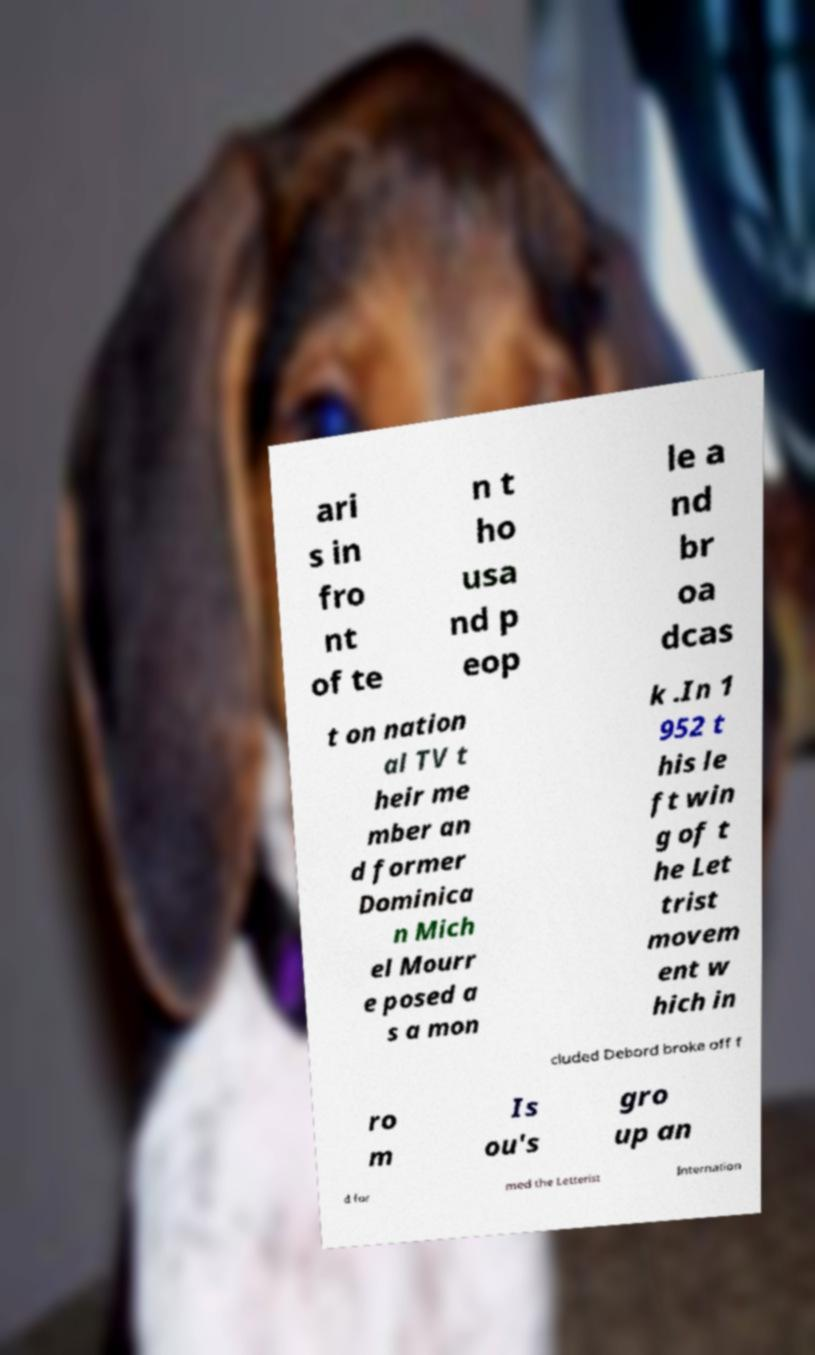Can you accurately transcribe the text from the provided image for me? ari s in fro nt of te n t ho usa nd p eop le a nd br oa dcas t on nation al TV t heir me mber an d former Dominica n Mich el Mourr e posed a s a mon k .In 1 952 t his le ft win g of t he Let trist movem ent w hich in cluded Debord broke off f ro m Is ou's gro up an d for med the Letterist Internation 